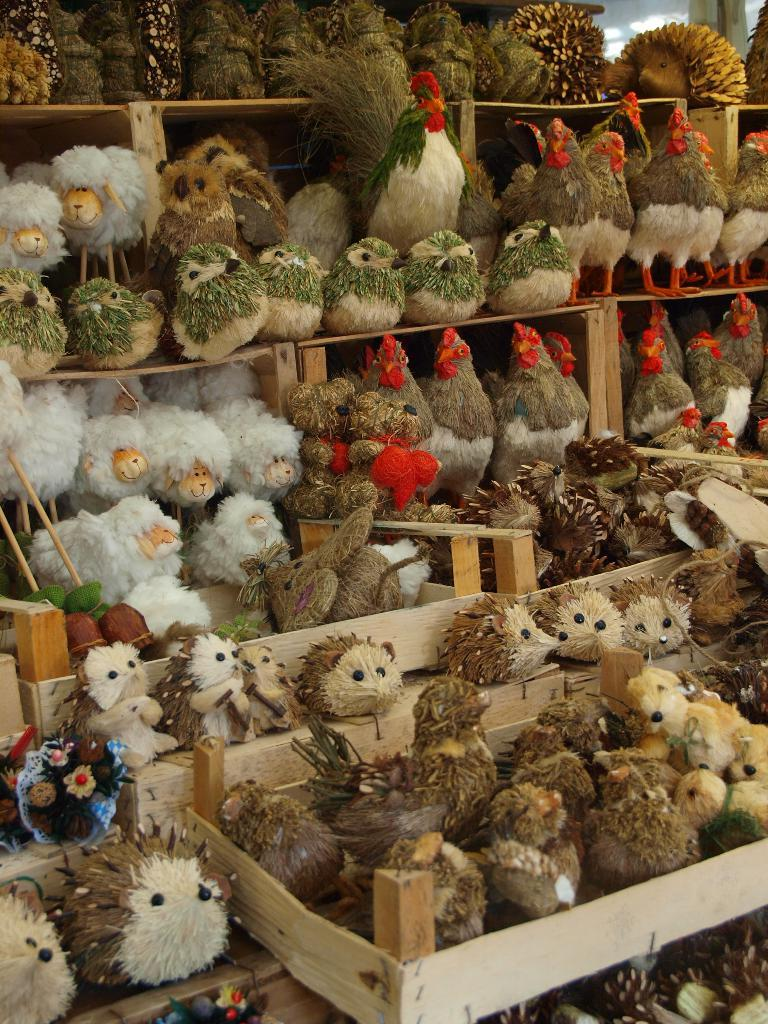What objects are present in the image? There are toys in the image. How are the toys arranged in the image? The toys are placed in a rack. What type of fish can be seen swimming in the image? There is no fish present in the image; it features toys placed in a rack. What advertisement is being displayed in the image? There is no advertisement present in the image; it only shows toys placed in a rack. 